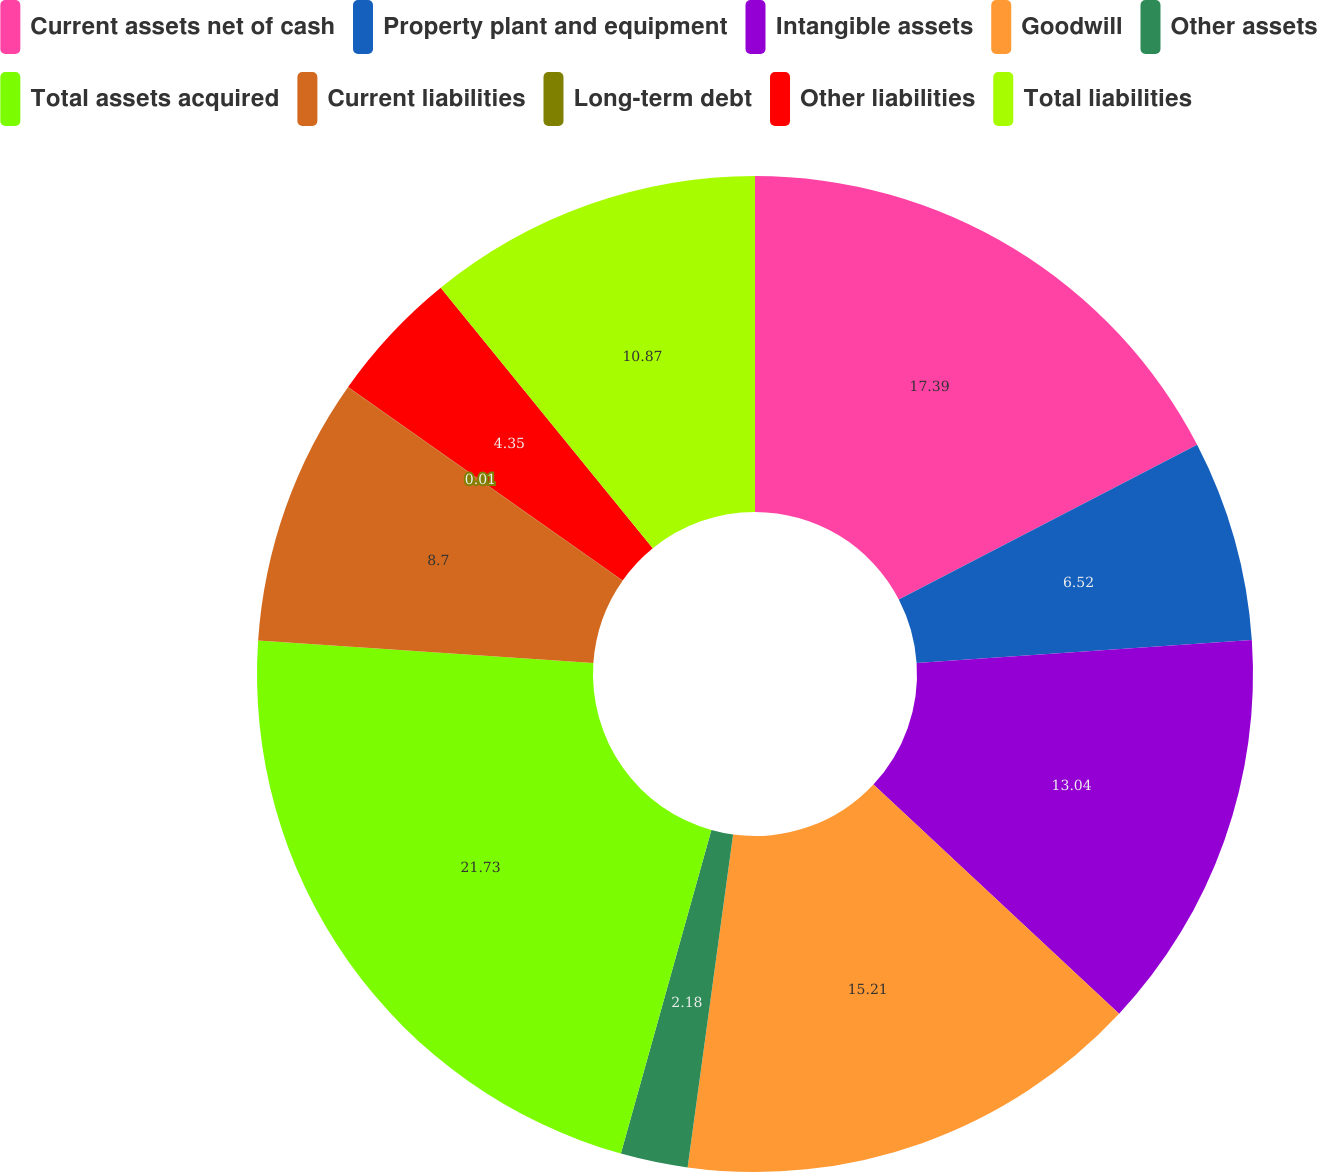<chart> <loc_0><loc_0><loc_500><loc_500><pie_chart><fcel>Current assets net of cash<fcel>Property plant and equipment<fcel>Intangible assets<fcel>Goodwill<fcel>Other assets<fcel>Total assets acquired<fcel>Current liabilities<fcel>Long-term debt<fcel>Other liabilities<fcel>Total liabilities<nl><fcel>17.39%<fcel>6.52%<fcel>13.04%<fcel>15.21%<fcel>2.18%<fcel>21.73%<fcel>8.7%<fcel>0.01%<fcel>4.35%<fcel>10.87%<nl></chart> 